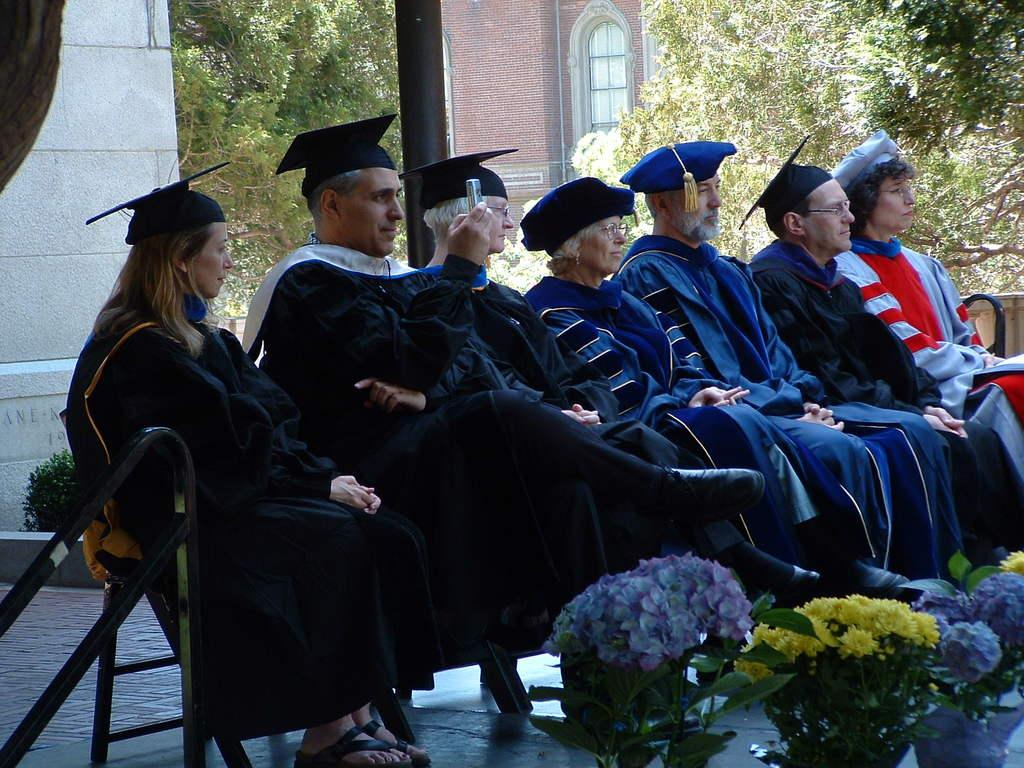How many people are in the image? There is a group of people in the image. What are the people doing in the image? The people are sitting on chairs. What can be seen in front of the people? There are flower plants in front of the people. What is visible behind the people? There are trees and a building behind the people. What is the price of the bike in the image? There is no bike present in the image. What can be seen in the aftermath of the event in the image? There is no event or aftermath depicted in the image; it shows a group of people sitting with flower plants, trees, and a building in the background. 